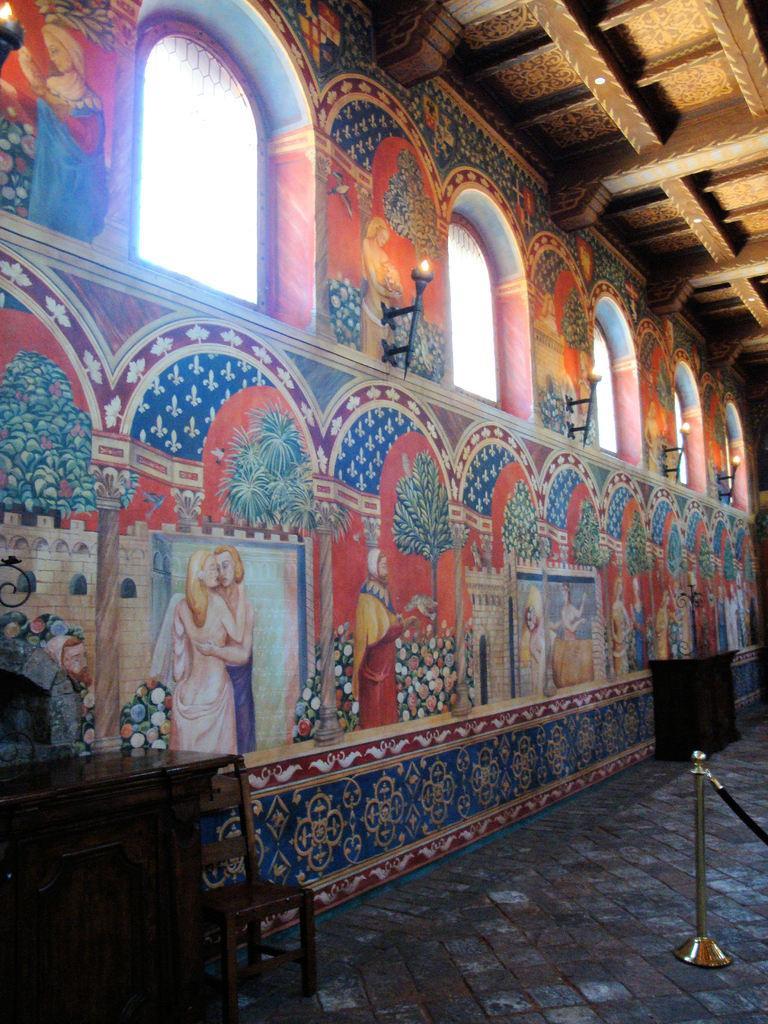Please provide a concise description of this image. This picture shows inner view of a building. We see glass Windows and painting on the wall and we see couple of cupboards and a chair and we see a rope fence and lights fixed to the wall. 